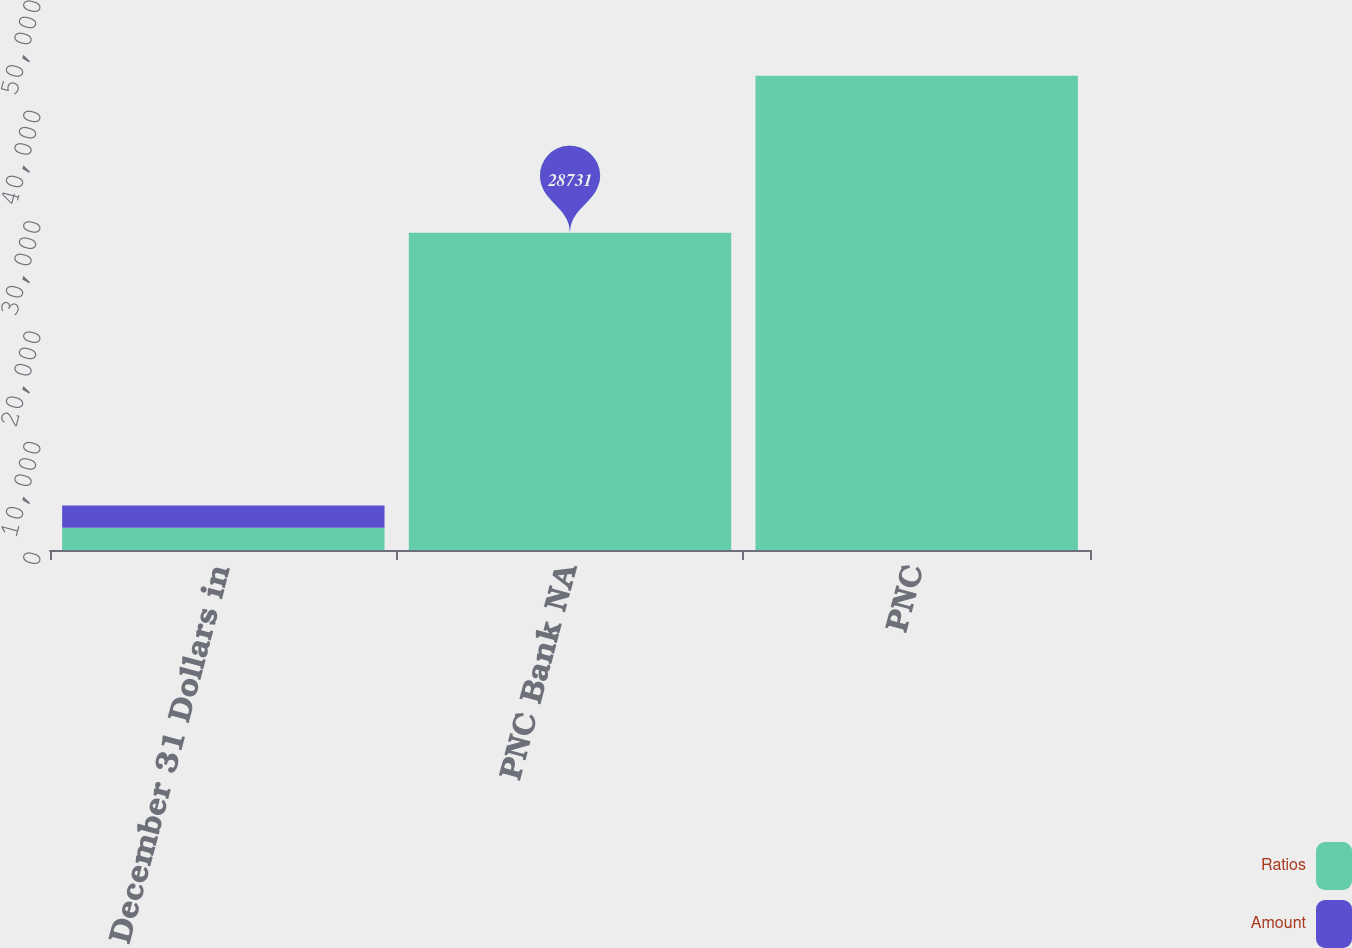<chart> <loc_0><loc_0><loc_500><loc_500><stacked_bar_chart><ecel><fcel>December 31 Dollars in<fcel>PNC Bank NA<fcel>PNC<nl><fcel>Ratios<fcel>2013<fcel>28731<fcel>42950<nl><fcel>Amount<fcel>2013<fcel>11<fcel>15.8<nl></chart> 